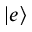<formula> <loc_0><loc_0><loc_500><loc_500>| e \rangle</formula> 